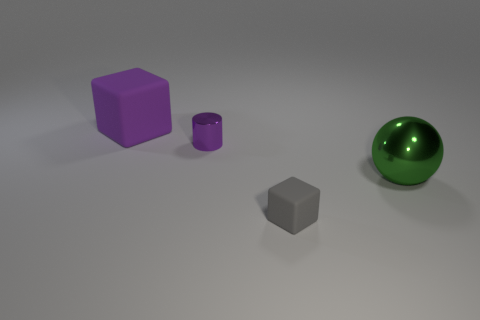Add 1 big shiny things. How many objects exist? 5 Subtract all spheres. How many objects are left? 3 Subtract all gray cubes. How many cubes are left? 1 Add 2 large green objects. How many large green objects exist? 3 Subtract 0 yellow spheres. How many objects are left? 4 Subtract 1 cubes. How many cubes are left? 1 Subtract all yellow cylinders. Subtract all green balls. How many cylinders are left? 1 Subtract all gray matte objects. Subtract all large gray cubes. How many objects are left? 3 Add 4 tiny cylinders. How many tiny cylinders are left? 5 